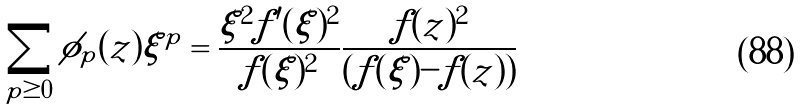<formula> <loc_0><loc_0><loc_500><loc_500>\sum _ { p \geq 0 } \phi _ { p } ( z ) \xi ^ { p } = \frac { \xi ^ { 2 } f ^ { \prime } ( \xi ) ^ { 2 } } { f ( \xi ) ^ { 2 } } \frac { f ( z ) ^ { 2 } } { ( f ( \xi ) - f ( z ) ) }</formula> 